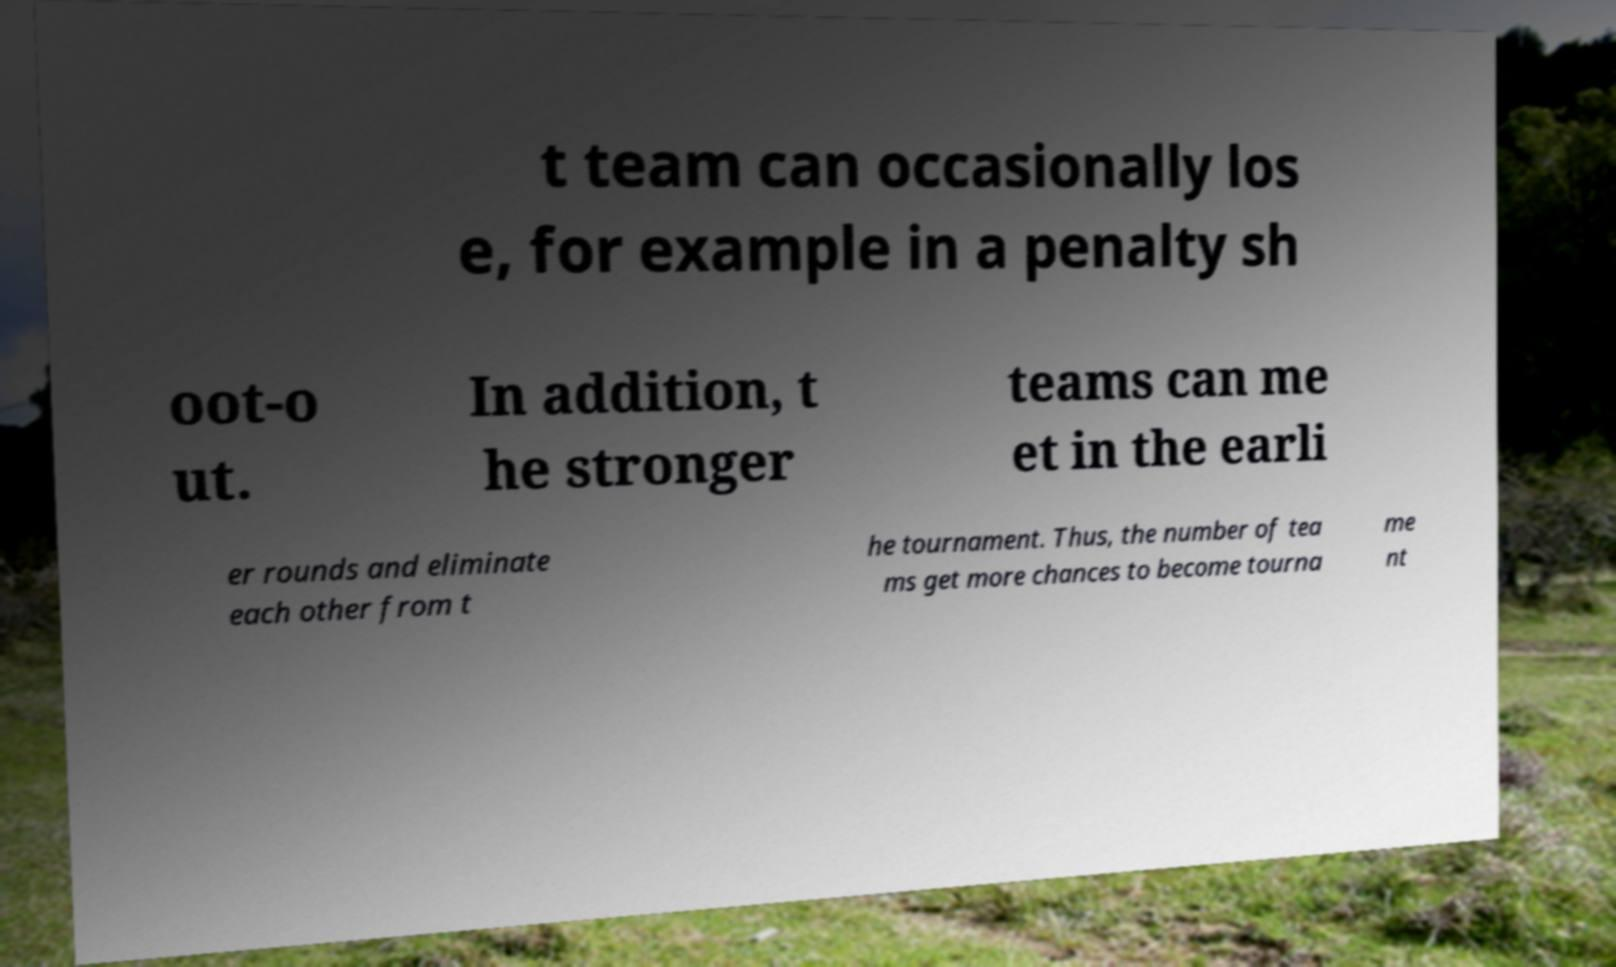I need the written content from this picture converted into text. Can you do that? t team can occasionally los e, for example in a penalty sh oot-o ut. In addition, t he stronger teams can me et in the earli er rounds and eliminate each other from t he tournament. Thus, the number of tea ms get more chances to become tourna me nt 